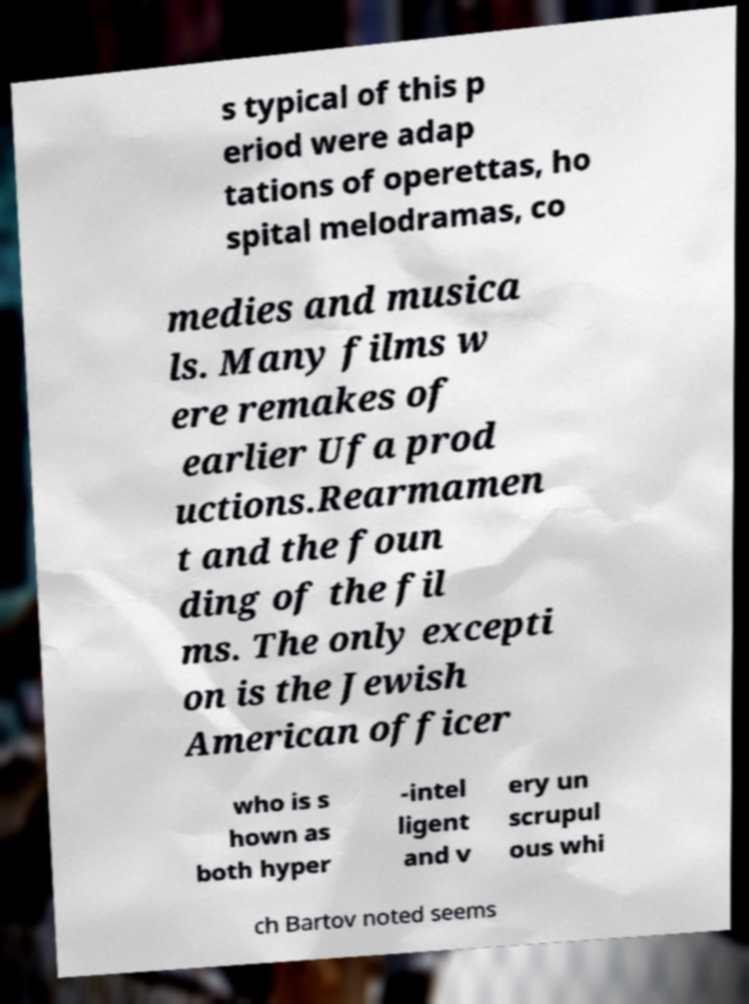I need the written content from this picture converted into text. Can you do that? s typical of this p eriod were adap tations of operettas, ho spital melodramas, co medies and musica ls. Many films w ere remakes of earlier Ufa prod uctions.Rearmamen t and the foun ding of the fil ms. The only excepti on is the Jewish American officer who is s hown as both hyper -intel ligent and v ery un scrupul ous whi ch Bartov noted seems 